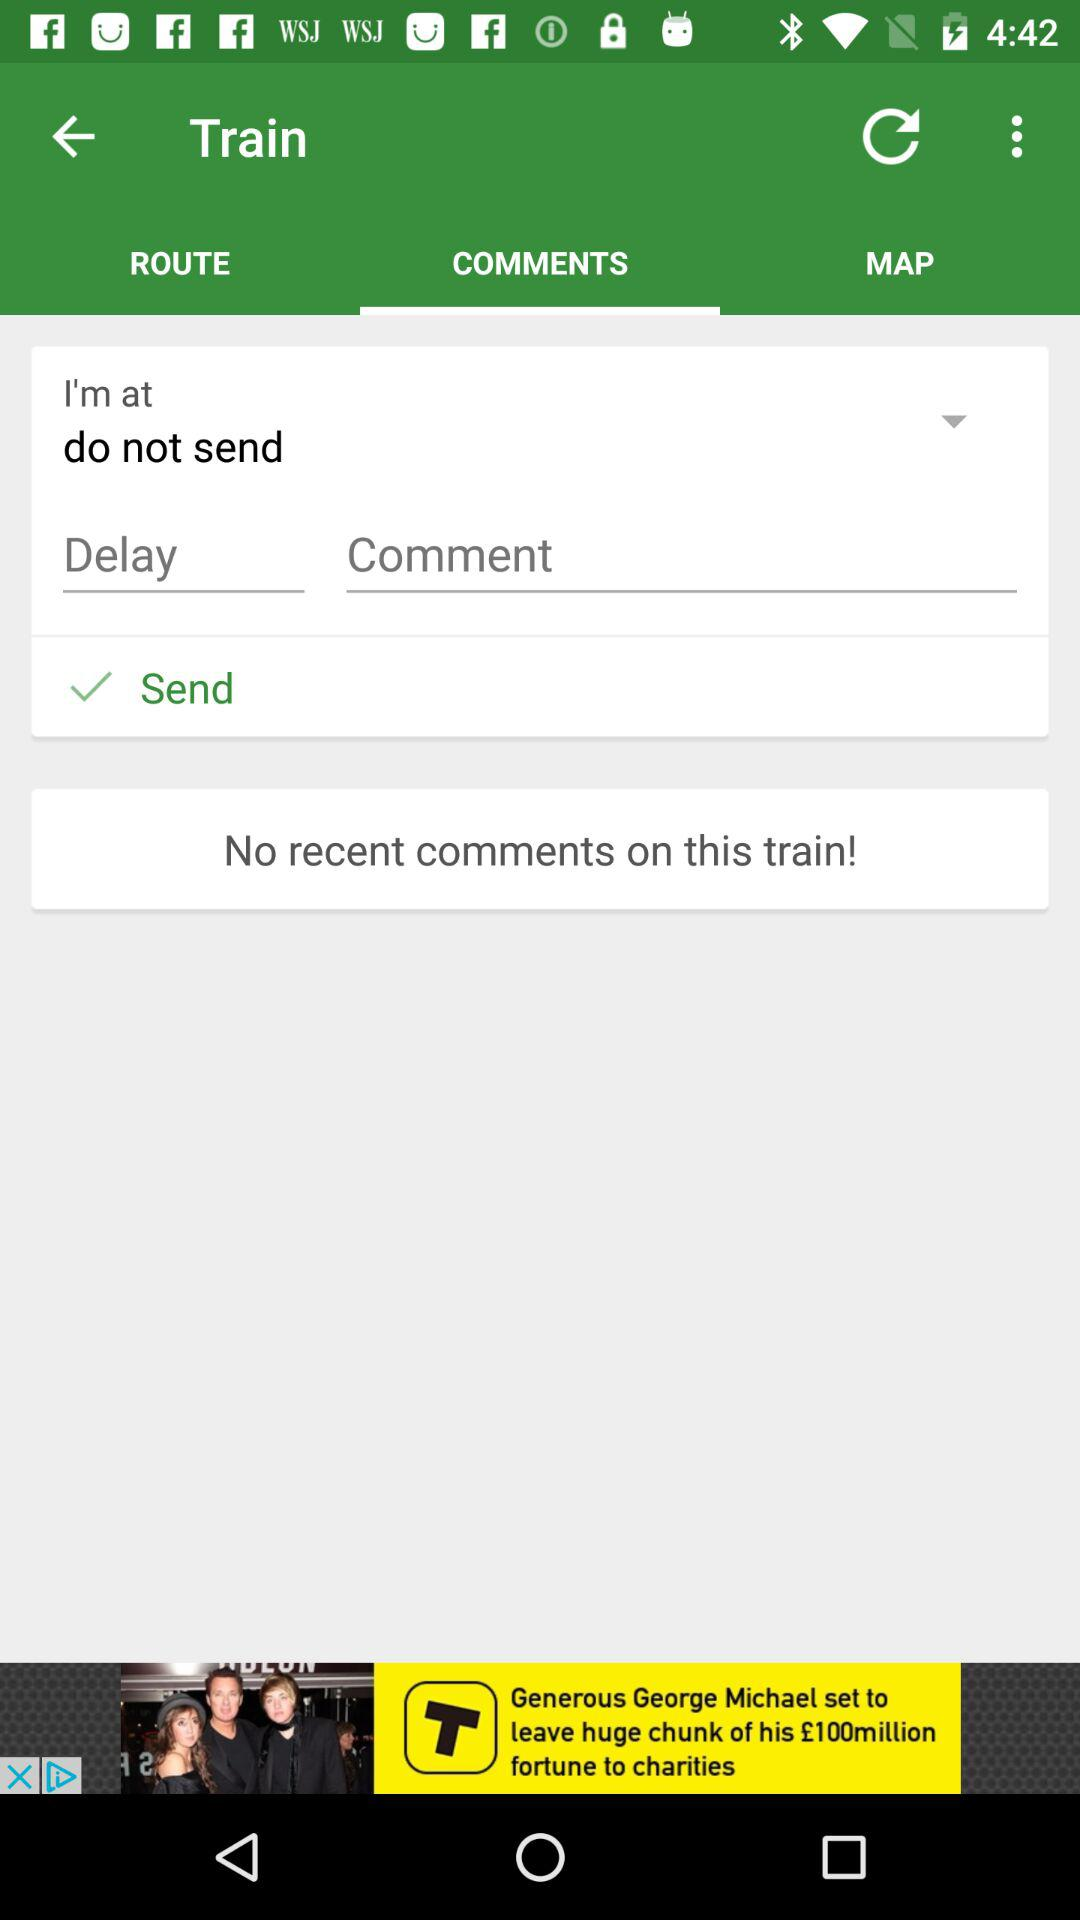Which tab has been selected? The tab that has been selected is "COMMENTS". 